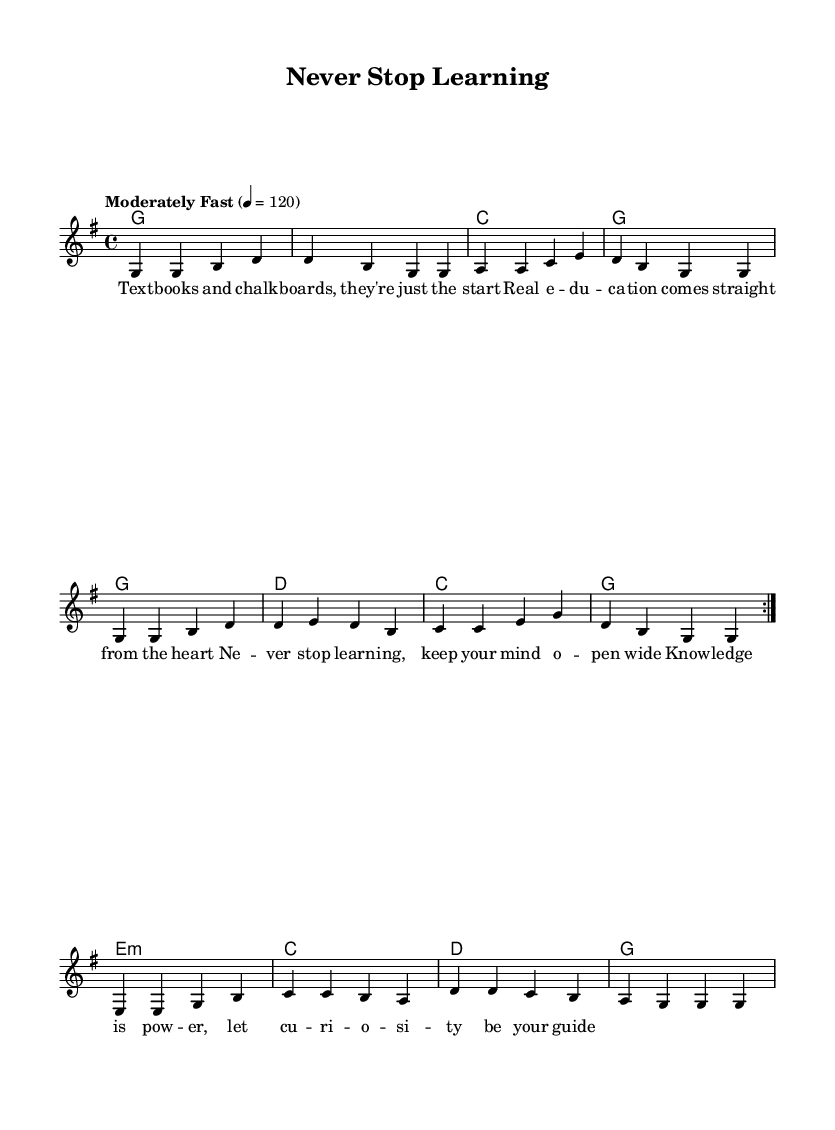What is the key signature of this music? The key signature is G major, indicated by one sharp (F#). You can determine this by looking at the key signature section at the beginning of the sheet music.
Answer: G major What is the time signature of this music? The time signature is 4/4, which means there are four beats per measure and each quarter note gets one beat. This is shown at the beginning of the sheet music next to the key signature.
Answer: 4/4 What is the tempo marking of this piece? The tempo marking indicates "Moderately Fast" at a tempo of 120 beats per minute. You can find this information at the top of the score, where tempo is described.
Answer: Moderately Fast How many volta sections are in the melody? There are two volta sections in the melody, indicated by the "repeat volta 2" within the melody notation. This means the section should be played twice.
Answer: 2 What lyrical theme does the song celebrate? The lyrical theme celebrates lifelong learning and education, emphasizing the importance of knowledge and curiosity throughout life. This can be inferred from the lyrics in the verse, which mention education and keeping an open mind.
Answer: Lifelong learning What harmonic progression is used in the first two measures? The harmonic progression in the first two measures is G major to C major, as indicated by the chord symbols placed above the melody. This is a common progression in country music.
Answer: G to C What is the last chord in the music? The last chord in the music is G major, as indicated in the harmony part of the sheet music. It concludes the piece, creating a sense of resolution.
Answer: G 